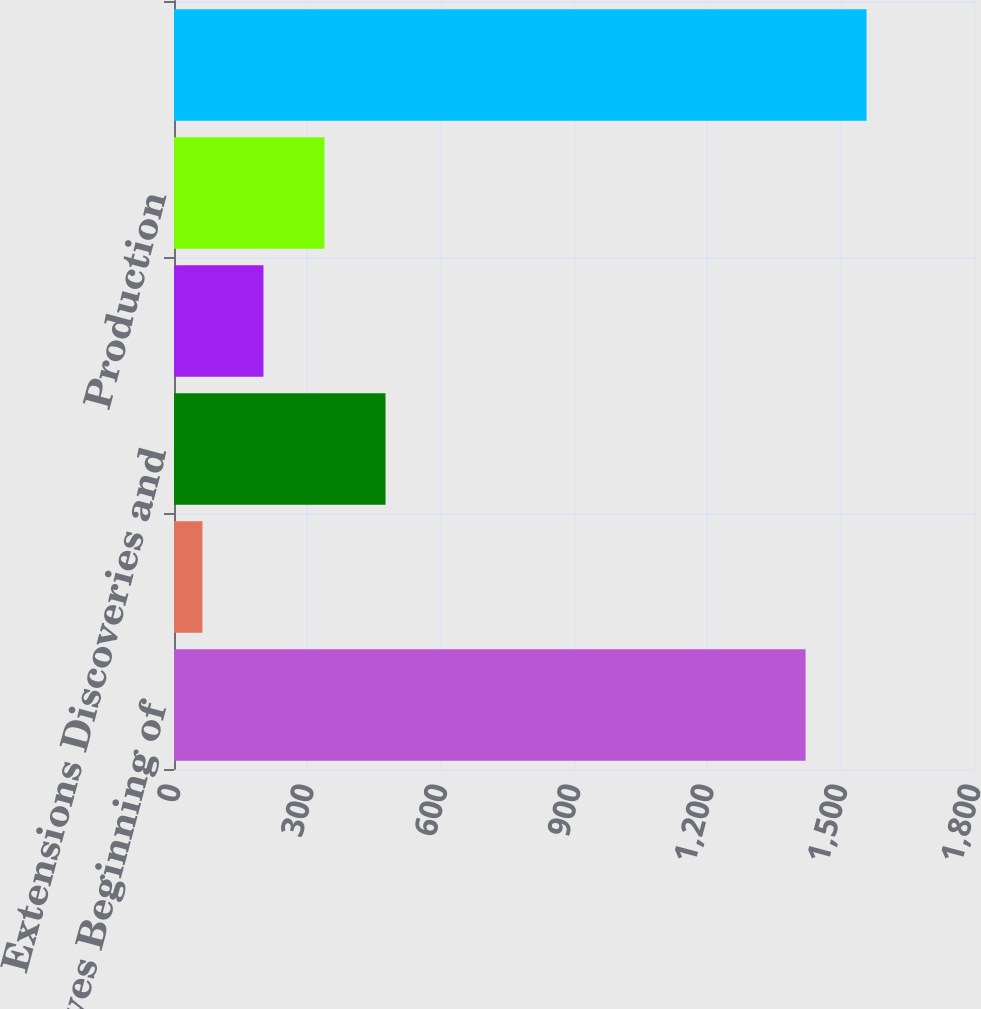<chart> <loc_0><loc_0><loc_500><loc_500><bar_chart><fcel>Proved Reserves Beginning of<fcel>Revisions of Previous<fcel>Extensions Discoveries and<fcel>Sale of Minerals in Place<fcel>Production<fcel>Proved Reserves End of Year<nl><fcel>1421<fcel>64<fcel>475.9<fcel>201.3<fcel>338.6<fcel>1558.3<nl></chart> 